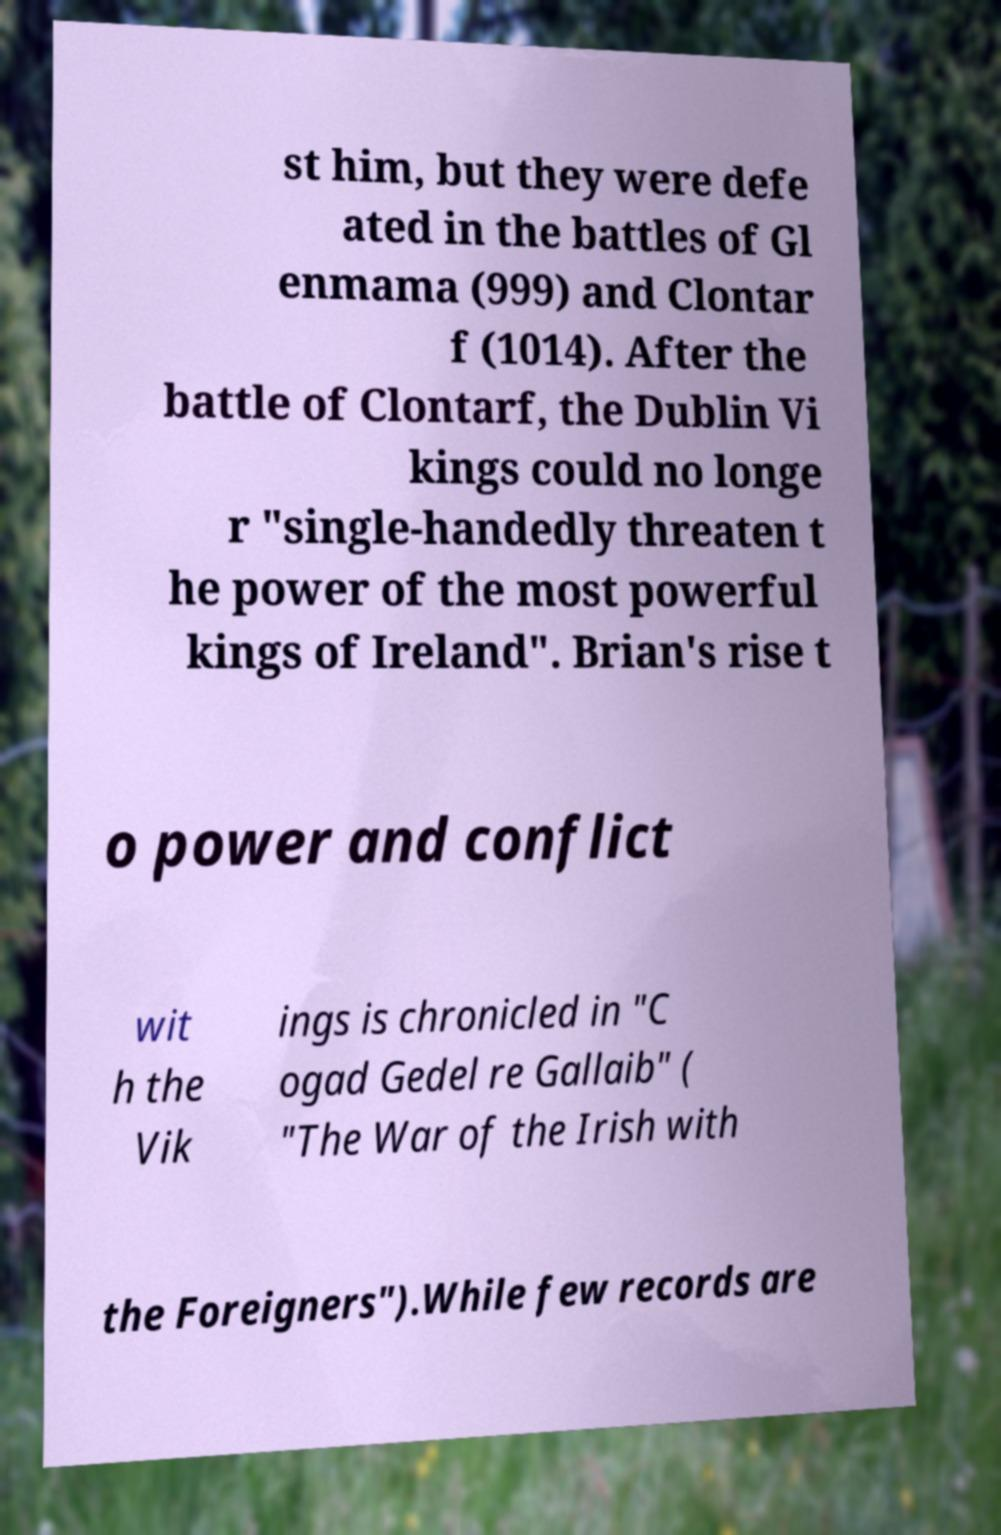There's text embedded in this image that I need extracted. Can you transcribe it verbatim? st him, but they were defe ated in the battles of Gl enmama (999) and Clontar f (1014). After the battle of Clontarf, the Dublin Vi kings could no longe r "single-handedly threaten t he power of the most powerful kings of Ireland". Brian's rise t o power and conflict wit h the Vik ings is chronicled in "C ogad Gedel re Gallaib" ( "The War of the Irish with the Foreigners").While few records are 